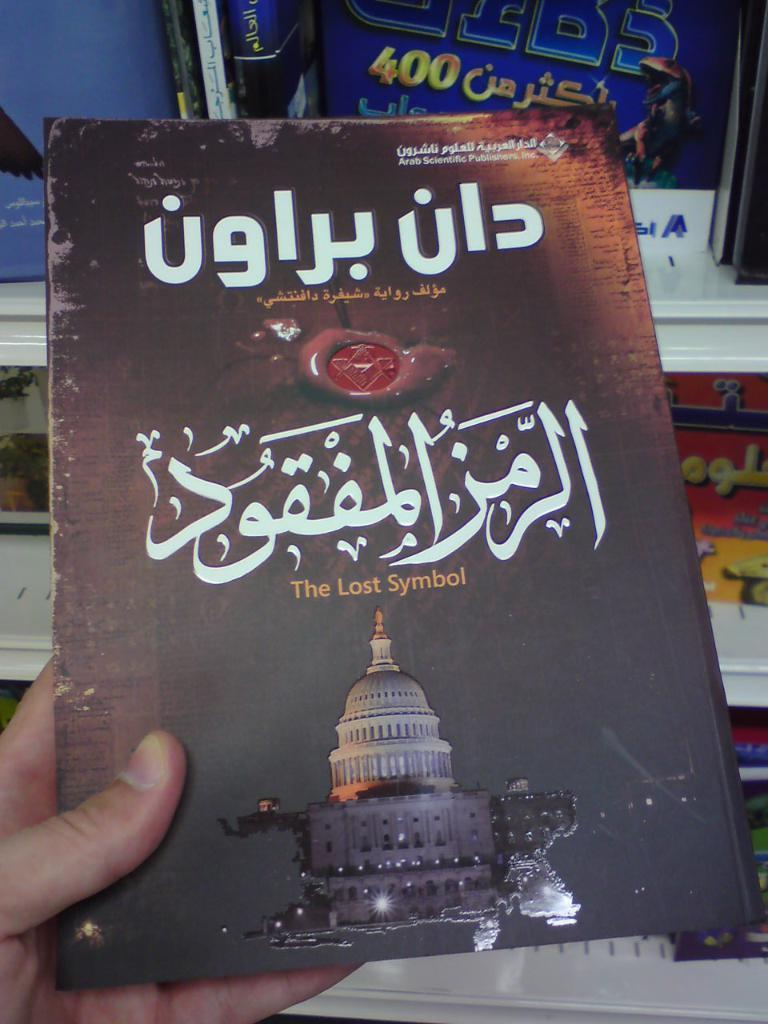<image>
Offer a succinct explanation of the picture presented. A copy of The Lost Symbol, that is translated into another language, is being held in someone's hand. 